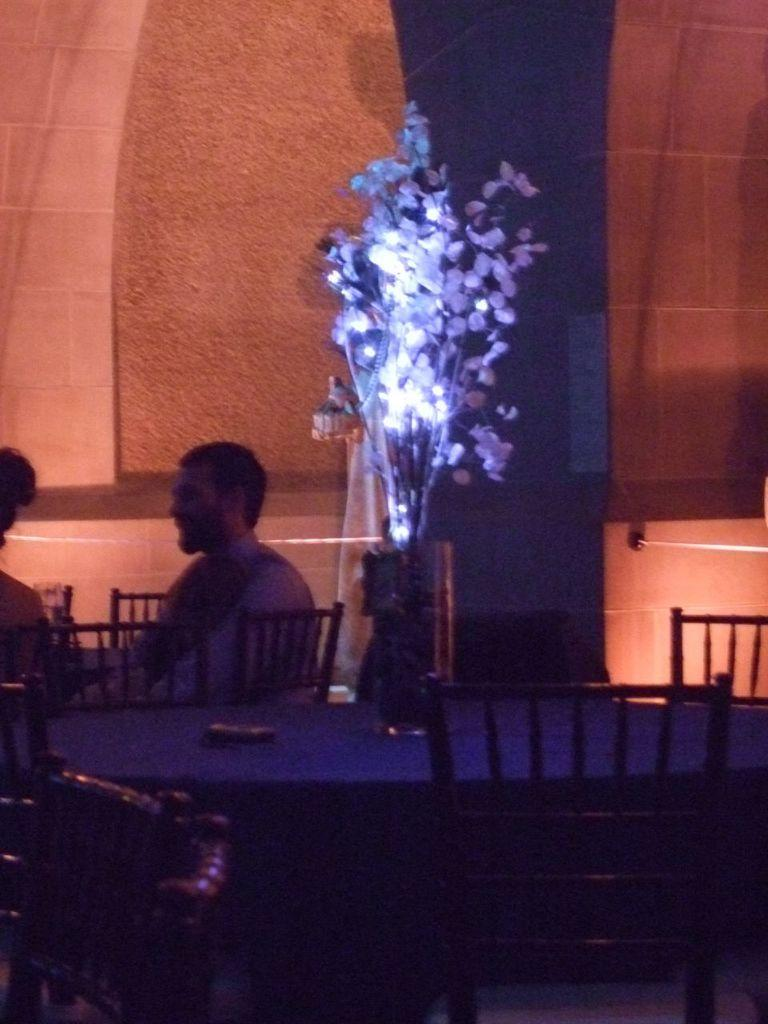What type of furniture is present in the image? There is a dining table in the image. What object is used for holding flowers? There is a flower flask in the image. How many people are visible on the left side of the image? There are two people on the left side of the image. What can be seen in the background of the image? There is a wall visible in the background of the image. What type of carriage is being used by the girls in the image? There are no girls or carriages present in the image. 